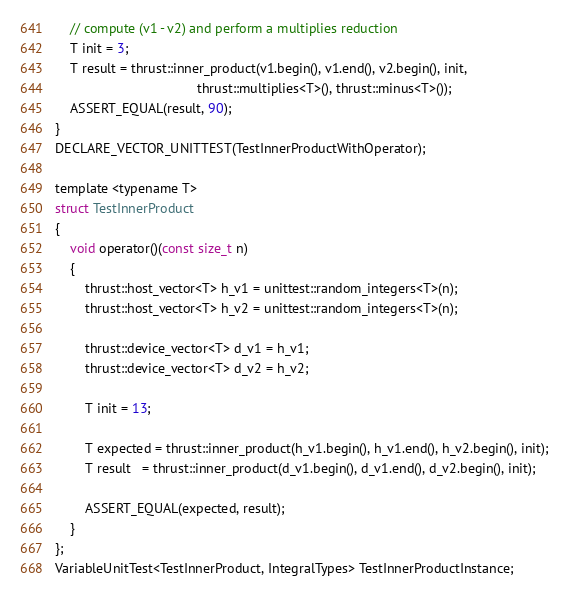<code> <loc_0><loc_0><loc_500><loc_500><_Cuda_>    // compute (v1 - v2) and perform a multiplies reduction
    T init = 3;
    T result = thrust::inner_product(v1.begin(), v1.end(), v2.begin(), init, 
                                      thrust::multiplies<T>(), thrust::minus<T>());
    ASSERT_EQUAL(result, 90);
}
DECLARE_VECTOR_UNITTEST(TestInnerProductWithOperator);

template <typename T>
struct TestInnerProduct
{
    void operator()(const size_t n)
    {
        thrust::host_vector<T> h_v1 = unittest::random_integers<T>(n);
        thrust::host_vector<T> h_v2 = unittest::random_integers<T>(n);

        thrust::device_vector<T> d_v1 = h_v1;
        thrust::device_vector<T> d_v2 = h_v2;

        T init = 13;

        T expected = thrust::inner_product(h_v1.begin(), h_v1.end(), h_v2.begin(), init);
        T result   = thrust::inner_product(d_v1.begin(), d_v1.end(), d_v2.begin(), init);

        ASSERT_EQUAL(expected, result);
    }
};
VariableUnitTest<TestInnerProduct, IntegralTypes> TestInnerProductInstance;


</code> 